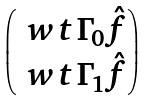Convert formula to latex. <formula><loc_0><loc_0><loc_500><loc_500>\begin{pmatrix} \ w t \Gamma _ { 0 } \hat { f } \\ \ w t \Gamma _ { 1 } \hat { f } \end{pmatrix}</formula> 